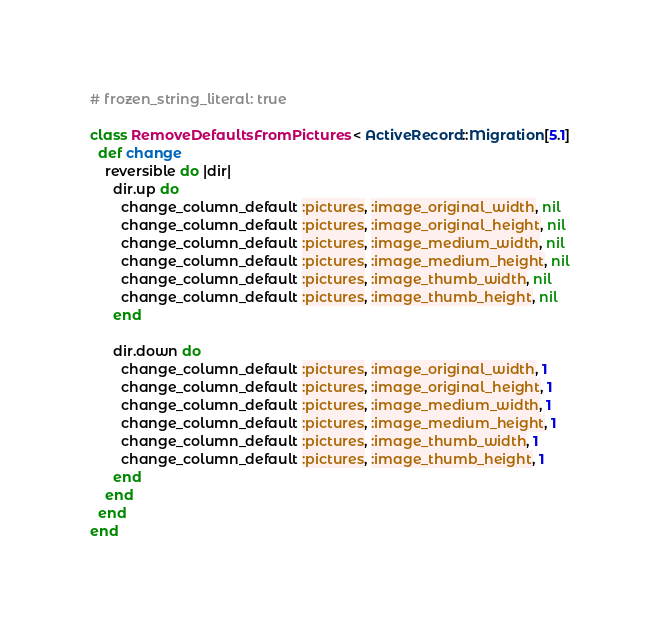Convert code to text. <code><loc_0><loc_0><loc_500><loc_500><_Ruby_># frozen_string_literal: true

class RemoveDefaultsFromPictures < ActiveRecord::Migration[5.1]
  def change
    reversible do |dir|
      dir.up do
        change_column_default :pictures, :image_original_width, nil
        change_column_default :pictures, :image_original_height, nil
        change_column_default :pictures, :image_medium_width, nil
        change_column_default :pictures, :image_medium_height, nil
        change_column_default :pictures, :image_thumb_width, nil
        change_column_default :pictures, :image_thumb_height, nil
      end

      dir.down do
        change_column_default :pictures, :image_original_width, 1
        change_column_default :pictures, :image_original_height, 1
        change_column_default :pictures, :image_medium_width, 1
        change_column_default :pictures, :image_medium_height, 1
        change_column_default :pictures, :image_thumb_width, 1
        change_column_default :pictures, :image_thumb_height, 1
      end
    end
  end
end
</code> 